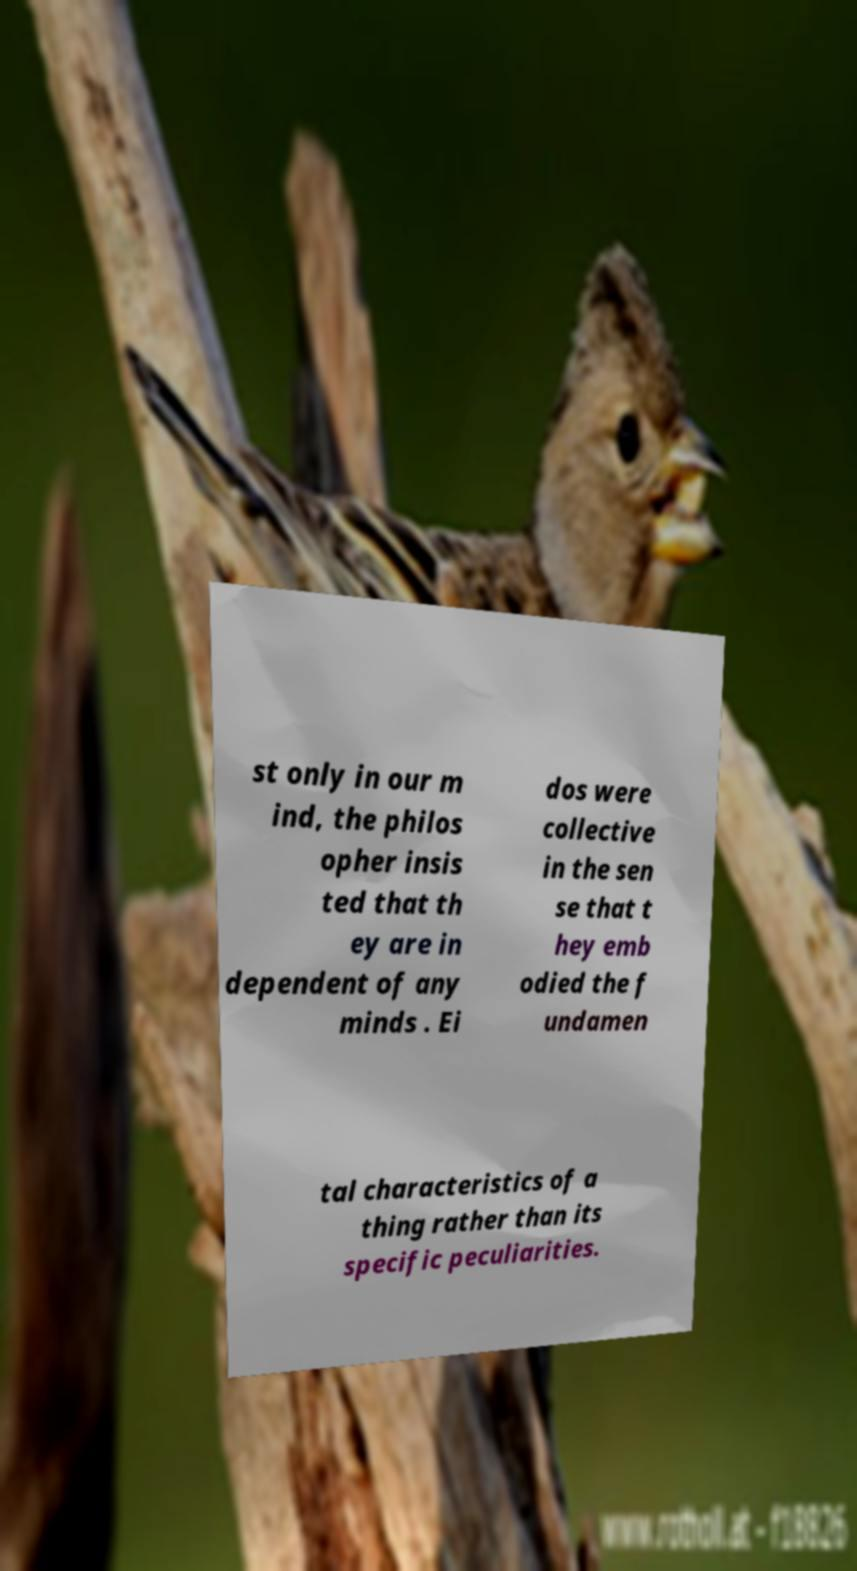Can you accurately transcribe the text from the provided image for me? st only in our m ind, the philos opher insis ted that th ey are in dependent of any minds . Ei dos were collective in the sen se that t hey emb odied the f undamen tal characteristics of a thing rather than its specific peculiarities. 